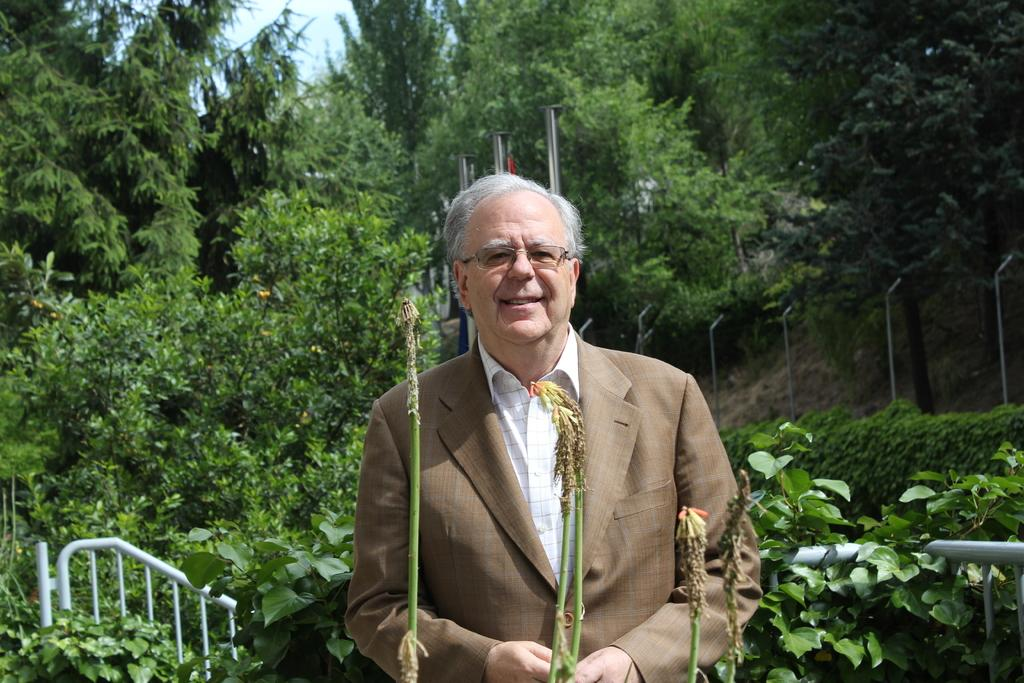What is the main subject of the image? There is a man standing in the image. Where is the man standing in relation to the plants? The man is standing between plants. What can be seen in the background of the image? There are trees and the sky visible in the background of the image. What type of structures are present in the image? There are iron grills and poles in the image. What type of notebook is the man using to stop the earth from spinning in the image? There is no notebook, earth, or indication of the man stopping the earth from spinning in the image. 